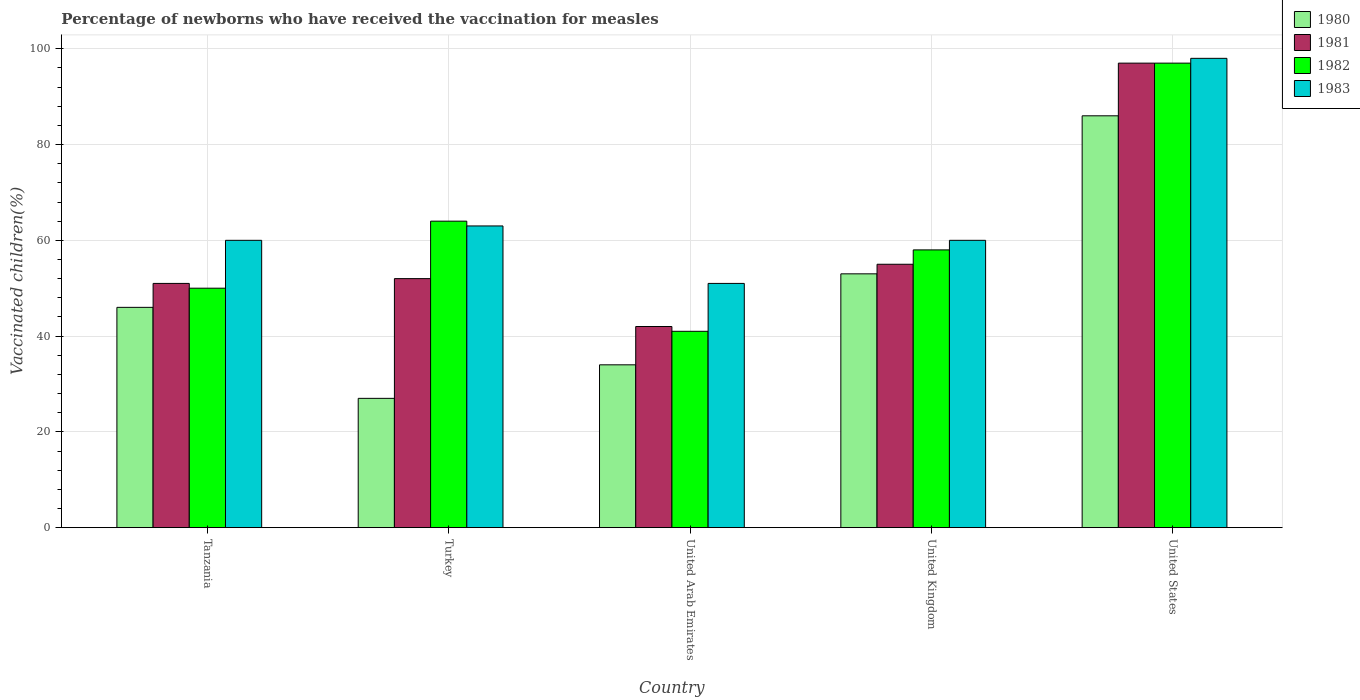How many different coloured bars are there?
Provide a short and direct response. 4. How many groups of bars are there?
Offer a very short reply. 5. How many bars are there on the 5th tick from the left?
Provide a succinct answer. 4. What is the label of the 3rd group of bars from the left?
Provide a short and direct response. United Arab Emirates. In how many cases, is the number of bars for a given country not equal to the number of legend labels?
Give a very brief answer. 0. What is the percentage of vaccinated children in 1980 in United Kingdom?
Make the answer very short. 53. Across all countries, what is the maximum percentage of vaccinated children in 1981?
Make the answer very short. 97. Across all countries, what is the minimum percentage of vaccinated children in 1983?
Provide a succinct answer. 51. In which country was the percentage of vaccinated children in 1983 maximum?
Give a very brief answer. United States. What is the total percentage of vaccinated children in 1982 in the graph?
Your response must be concise. 310. What is the difference between the percentage of vaccinated children in 1980 in Tanzania and that in Turkey?
Offer a terse response. 19. What is the difference between the percentage of vaccinated children of/in 1983 and percentage of vaccinated children of/in 1981 in Turkey?
Provide a short and direct response. 11. What is the ratio of the percentage of vaccinated children in 1982 in United Arab Emirates to that in United Kingdom?
Offer a terse response. 0.71. Is the percentage of vaccinated children in 1983 in Turkey less than that in United Arab Emirates?
Keep it short and to the point. No. Is the difference between the percentage of vaccinated children in 1983 in Tanzania and Turkey greater than the difference between the percentage of vaccinated children in 1981 in Tanzania and Turkey?
Your answer should be very brief. No. What is the difference between the highest and the second highest percentage of vaccinated children in 1982?
Provide a succinct answer. -33. Is the sum of the percentage of vaccinated children in 1980 in Turkey and United States greater than the maximum percentage of vaccinated children in 1983 across all countries?
Your answer should be very brief. Yes. Is it the case that in every country, the sum of the percentage of vaccinated children in 1983 and percentage of vaccinated children in 1980 is greater than the sum of percentage of vaccinated children in 1982 and percentage of vaccinated children in 1981?
Keep it short and to the point. No. What does the 2nd bar from the right in Tanzania represents?
Provide a short and direct response. 1982. How many countries are there in the graph?
Give a very brief answer. 5. What is the difference between two consecutive major ticks on the Y-axis?
Offer a very short reply. 20. Does the graph contain any zero values?
Ensure brevity in your answer.  No. Does the graph contain grids?
Your response must be concise. Yes. Where does the legend appear in the graph?
Give a very brief answer. Top right. How are the legend labels stacked?
Make the answer very short. Vertical. What is the title of the graph?
Make the answer very short. Percentage of newborns who have received the vaccination for measles. Does "2003" appear as one of the legend labels in the graph?
Your response must be concise. No. What is the label or title of the Y-axis?
Give a very brief answer. Vaccinated children(%). What is the Vaccinated children(%) in 1983 in Tanzania?
Your response must be concise. 60. What is the Vaccinated children(%) of 1982 in Turkey?
Provide a short and direct response. 64. What is the Vaccinated children(%) of 1982 in United Arab Emirates?
Your answer should be compact. 41. What is the Vaccinated children(%) in 1983 in United Kingdom?
Provide a succinct answer. 60. What is the Vaccinated children(%) of 1981 in United States?
Offer a terse response. 97. What is the Vaccinated children(%) in 1982 in United States?
Make the answer very short. 97. What is the Vaccinated children(%) in 1983 in United States?
Your answer should be compact. 98. Across all countries, what is the maximum Vaccinated children(%) in 1981?
Provide a succinct answer. 97. Across all countries, what is the maximum Vaccinated children(%) in 1982?
Your answer should be very brief. 97. Across all countries, what is the maximum Vaccinated children(%) in 1983?
Provide a short and direct response. 98. Across all countries, what is the minimum Vaccinated children(%) in 1980?
Give a very brief answer. 27. What is the total Vaccinated children(%) of 1980 in the graph?
Your answer should be compact. 246. What is the total Vaccinated children(%) in 1981 in the graph?
Keep it short and to the point. 297. What is the total Vaccinated children(%) in 1982 in the graph?
Offer a very short reply. 310. What is the total Vaccinated children(%) of 1983 in the graph?
Your answer should be compact. 332. What is the difference between the Vaccinated children(%) in 1981 in Tanzania and that in Turkey?
Offer a terse response. -1. What is the difference between the Vaccinated children(%) of 1982 in Tanzania and that in Turkey?
Provide a succinct answer. -14. What is the difference between the Vaccinated children(%) in 1983 in Tanzania and that in Turkey?
Your answer should be very brief. -3. What is the difference between the Vaccinated children(%) in 1983 in Tanzania and that in United Arab Emirates?
Your answer should be compact. 9. What is the difference between the Vaccinated children(%) in 1981 in Tanzania and that in United Kingdom?
Your response must be concise. -4. What is the difference between the Vaccinated children(%) in 1983 in Tanzania and that in United Kingdom?
Keep it short and to the point. 0. What is the difference between the Vaccinated children(%) of 1981 in Tanzania and that in United States?
Provide a succinct answer. -46. What is the difference between the Vaccinated children(%) in 1982 in Tanzania and that in United States?
Your answer should be compact. -47. What is the difference between the Vaccinated children(%) in 1983 in Tanzania and that in United States?
Offer a very short reply. -38. What is the difference between the Vaccinated children(%) in 1981 in Turkey and that in United Arab Emirates?
Give a very brief answer. 10. What is the difference between the Vaccinated children(%) in 1982 in Turkey and that in United Arab Emirates?
Your response must be concise. 23. What is the difference between the Vaccinated children(%) of 1983 in Turkey and that in United Arab Emirates?
Your answer should be compact. 12. What is the difference between the Vaccinated children(%) of 1980 in Turkey and that in United Kingdom?
Offer a terse response. -26. What is the difference between the Vaccinated children(%) in 1982 in Turkey and that in United Kingdom?
Provide a succinct answer. 6. What is the difference between the Vaccinated children(%) of 1983 in Turkey and that in United Kingdom?
Your response must be concise. 3. What is the difference between the Vaccinated children(%) of 1980 in Turkey and that in United States?
Your response must be concise. -59. What is the difference between the Vaccinated children(%) of 1981 in Turkey and that in United States?
Provide a succinct answer. -45. What is the difference between the Vaccinated children(%) in 1982 in Turkey and that in United States?
Your answer should be very brief. -33. What is the difference between the Vaccinated children(%) of 1983 in Turkey and that in United States?
Your answer should be compact. -35. What is the difference between the Vaccinated children(%) in 1980 in United Arab Emirates and that in United Kingdom?
Your answer should be compact. -19. What is the difference between the Vaccinated children(%) in 1983 in United Arab Emirates and that in United Kingdom?
Your response must be concise. -9. What is the difference between the Vaccinated children(%) of 1980 in United Arab Emirates and that in United States?
Ensure brevity in your answer.  -52. What is the difference between the Vaccinated children(%) in 1981 in United Arab Emirates and that in United States?
Your response must be concise. -55. What is the difference between the Vaccinated children(%) in 1982 in United Arab Emirates and that in United States?
Provide a short and direct response. -56. What is the difference between the Vaccinated children(%) of 1983 in United Arab Emirates and that in United States?
Provide a short and direct response. -47. What is the difference between the Vaccinated children(%) of 1980 in United Kingdom and that in United States?
Make the answer very short. -33. What is the difference between the Vaccinated children(%) of 1981 in United Kingdom and that in United States?
Offer a terse response. -42. What is the difference between the Vaccinated children(%) in 1982 in United Kingdom and that in United States?
Your answer should be very brief. -39. What is the difference between the Vaccinated children(%) in 1983 in United Kingdom and that in United States?
Give a very brief answer. -38. What is the difference between the Vaccinated children(%) of 1981 in Tanzania and the Vaccinated children(%) of 1982 in Turkey?
Give a very brief answer. -13. What is the difference between the Vaccinated children(%) of 1980 in Tanzania and the Vaccinated children(%) of 1982 in United Arab Emirates?
Give a very brief answer. 5. What is the difference between the Vaccinated children(%) in 1980 in Tanzania and the Vaccinated children(%) in 1983 in United Arab Emirates?
Offer a very short reply. -5. What is the difference between the Vaccinated children(%) of 1981 in Tanzania and the Vaccinated children(%) of 1983 in United Arab Emirates?
Your response must be concise. 0. What is the difference between the Vaccinated children(%) of 1981 in Tanzania and the Vaccinated children(%) of 1982 in United Kingdom?
Your answer should be very brief. -7. What is the difference between the Vaccinated children(%) in 1981 in Tanzania and the Vaccinated children(%) in 1983 in United Kingdom?
Your response must be concise. -9. What is the difference between the Vaccinated children(%) of 1982 in Tanzania and the Vaccinated children(%) of 1983 in United Kingdom?
Your answer should be very brief. -10. What is the difference between the Vaccinated children(%) in 1980 in Tanzania and the Vaccinated children(%) in 1981 in United States?
Provide a succinct answer. -51. What is the difference between the Vaccinated children(%) of 1980 in Tanzania and the Vaccinated children(%) of 1982 in United States?
Keep it short and to the point. -51. What is the difference between the Vaccinated children(%) in 1980 in Tanzania and the Vaccinated children(%) in 1983 in United States?
Offer a very short reply. -52. What is the difference between the Vaccinated children(%) of 1981 in Tanzania and the Vaccinated children(%) of 1982 in United States?
Offer a very short reply. -46. What is the difference between the Vaccinated children(%) in 1981 in Tanzania and the Vaccinated children(%) in 1983 in United States?
Your answer should be compact. -47. What is the difference between the Vaccinated children(%) of 1982 in Tanzania and the Vaccinated children(%) of 1983 in United States?
Give a very brief answer. -48. What is the difference between the Vaccinated children(%) of 1980 in Turkey and the Vaccinated children(%) of 1983 in United Arab Emirates?
Keep it short and to the point. -24. What is the difference between the Vaccinated children(%) in 1981 in Turkey and the Vaccinated children(%) in 1982 in United Arab Emirates?
Provide a short and direct response. 11. What is the difference between the Vaccinated children(%) of 1980 in Turkey and the Vaccinated children(%) of 1981 in United Kingdom?
Keep it short and to the point. -28. What is the difference between the Vaccinated children(%) of 1980 in Turkey and the Vaccinated children(%) of 1982 in United Kingdom?
Your answer should be very brief. -31. What is the difference between the Vaccinated children(%) of 1980 in Turkey and the Vaccinated children(%) of 1983 in United Kingdom?
Your answer should be compact. -33. What is the difference between the Vaccinated children(%) of 1982 in Turkey and the Vaccinated children(%) of 1983 in United Kingdom?
Offer a very short reply. 4. What is the difference between the Vaccinated children(%) in 1980 in Turkey and the Vaccinated children(%) in 1981 in United States?
Provide a succinct answer. -70. What is the difference between the Vaccinated children(%) of 1980 in Turkey and the Vaccinated children(%) of 1982 in United States?
Ensure brevity in your answer.  -70. What is the difference between the Vaccinated children(%) of 1980 in Turkey and the Vaccinated children(%) of 1983 in United States?
Your response must be concise. -71. What is the difference between the Vaccinated children(%) in 1981 in Turkey and the Vaccinated children(%) in 1982 in United States?
Keep it short and to the point. -45. What is the difference between the Vaccinated children(%) of 1981 in Turkey and the Vaccinated children(%) of 1983 in United States?
Ensure brevity in your answer.  -46. What is the difference between the Vaccinated children(%) of 1982 in Turkey and the Vaccinated children(%) of 1983 in United States?
Give a very brief answer. -34. What is the difference between the Vaccinated children(%) of 1980 in United Arab Emirates and the Vaccinated children(%) of 1982 in United Kingdom?
Provide a succinct answer. -24. What is the difference between the Vaccinated children(%) of 1980 in United Arab Emirates and the Vaccinated children(%) of 1983 in United Kingdom?
Your answer should be compact. -26. What is the difference between the Vaccinated children(%) of 1981 in United Arab Emirates and the Vaccinated children(%) of 1982 in United Kingdom?
Your response must be concise. -16. What is the difference between the Vaccinated children(%) of 1982 in United Arab Emirates and the Vaccinated children(%) of 1983 in United Kingdom?
Your response must be concise. -19. What is the difference between the Vaccinated children(%) in 1980 in United Arab Emirates and the Vaccinated children(%) in 1981 in United States?
Ensure brevity in your answer.  -63. What is the difference between the Vaccinated children(%) of 1980 in United Arab Emirates and the Vaccinated children(%) of 1982 in United States?
Your answer should be very brief. -63. What is the difference between the Vaccinated children(%) in 1980 in United Arab Emirates and the Vaccinated children(%) in 1983 in United States?
Ensure brevity in your answer.  -64. What is the difference between the Vaccinated children(%) of 1981 in United Arab Emirates and the Vaccinated children(%) of 1982 in United States?
Your answer should be very brief. -55. What is the difference between the Vaccinated children(%) in 1981 in United Arab Emirates and the Vaccinated children(%) in 1983 in United States?
Your answer should be very brief. -56. What is the difference between the Vaccinated children(%) of 1982 in United Arab Emirates and the Vaccinated children(%) of 1983 in United States?
Make the answer very short. -57. What is the difference between the Vaccinated children(%) of 1980 in United Kingdom and the Vaccinated children(%) of 1981 in United States?
Give a very brief answer. -44. What is the difference between the Vaccinated children(%) in 1980 in United Kingdom and the Vaccinated children(%) in 1982 in United States?
Your answer should be very brief. -44. What is the difference between the Vaccinated children(%) in 1980 in United Kingdom and the Vaccinated children(%) in 1983 in United States?
Provide a succinct answer. -45. What is the difference between the Vaccinated children(%) of 1981 in United Kingdom and the Vaccinated children(%) of 1982 in United States?
Ensure brevity in your answer.  -42. What is the difference between the Vaccinated children(%) in 1981 in United Kingdom and the Vaccinated children(%) in 1983 in United States?
Keep it short and to the point. -43. What is the difference between the Vaccinated children(%) in 1982 in United Kingdom and the Vaccinated children(%) in 1983 in United States?
Make the answer very short. -40. What is the average Vaccinated children(%) of 1980 per country?
Your answer should be compact. 49.2. What is the average Vaccinated children(%) in 1981 per country?
Offer a very short reply. 59.4. What is the average Vaccinated children(%) in 1983 per country?
Give a very brief answer. 66.4. What is the difference between the Vaccinated children(%) of 1980 and Vaccinated children(%) of 1981 in Tanzania?
Give a very brief answer. -5. What is the difference between the Vaccinated children(%) of 1981 and Vaccinated children(%) of 1982 in Tanzania?
Your answer should be very brief. 1. What is the difference between the Vaccinated children(%) in 1982 and Vaccinated children(%) in 1983 in Tanzania?
Keep it short and to the point. -10. What is the difference between the Vaccinated children(%) of 1980 and Vaccinated children(%) of 1982 in Turkey?
Provide a short and direct response. -37. What is the difference between the Vaccinated children(%) in 1980 and Vaccinated children(%) in 1983 in Turkey?
Your answer should be very brief. -36. What is the difference between the Vaccinated children(%) of 1981 and Vaccinated children(%) of 1982 in Turkey?
Keep it short and to the point. -12. What is the difference between the Vaccinated children(%) of 1981 and Vaccinated children(%) of 1983 in Turkey?
Ensure brevity in your answer.  -11. What is the difference between the Vaccinated children(%) in 1982 and Vaccinated children(%) in 1983 in Turkey?
Keep it short and to the point. 1. What is the difference between the Vaccinated children(%) of 1980 and Vaccinated children(%) of 1981 in United Arab Emirates?
Offer a very short reply. -8. What is the difference between the Vaccinated children(%) in 1980 and Vaccinated children(%) in 1982 in United Arab Emirates?
Provide a succinct answer. -7. What is the difference between the Vaccinated children(%) of 1980 and Vaccinated children(%) of 1983 in United Arab Emirates?
Your answer should be compact. -17. What is the difference between the Vaccinated children(%) in 1981 and Vaccinated children(%) in 1983 in United Arab Emirates?
Give a very brief answer. -9. What is the difference between the Vaccinated children(%) of 1980 and Vaccinated children(%) of 1981 in United Kingdom?
Give a very brief answer. -2. What is the difference between the Vaccinated children(%) of 1980 and Vaccinated children(%) of 1982 in United Kingdom?
Make the answer very short. -5. What is the difference between the Vaccinated children(%) in 1981 and Vaccinated children(%) in 1982 in United Kingdom?
Your answer should be compact. -3. What is the difference between the Vaccinated children(%) in 1981 and Vaccinated children(%) in 1983 in United Kingdom?
Provide a short and direct response. -5. What is the difference between the Vaccinated children(%) in 1982 and Vaccinated children(%) in 1983 in United Kingdom?
Your response must be concise. -2. What is the difference between the Vaccinated children(%) in 1980 and Vaccinated children(%) in 1981 in United States?
Ensure brevity in your answer.  -11. What is the difference between the Vaccinated children(%) of 1980 and Vaccinated children(%) of 1983 in United States?
Ensure brevity in your answer.  -12. What is the difference between the Vaccinated children(%) of 1981 and Vaccinated children(%) of 1982 in United States?
Provide a short and direct response. 0. What is the difference between the Vaccinated children(%) of 1981 and Vaccinated children(%) of 1983 in United States?
Your response must be concise. -1. What is the difference between the Vaccinated children(%) of 1982 and Vaccinated children(%) of 1983 in United States?
Provide a succinct answer. -1. What is the ratio of the Vaccinated children(%) in 1980 in Tanzania to that in Turkey?
Offer a very short reply. 1.7. What is the ratio of the Vaccinated children(%) of 1981 in Tanzania to that in Turkey?
Provide a succinct answer. 0.98. What is the ratio of the Vaccinated children(%) of 1982 in Tanzania to that in Turkey?
Make the answer very short. 0.78. What is the ratio of the Vaccinated children(%) of 1983 in Tanzania to that in Turkey?
Provide a short and direct response. 0.95. What is the ratio of the Vaccinated children(%) in 1980 in Tanzania to that in United Arab Emirates?
Provide a short and direct response. 1.35. What is the ratio of the Vaccinated children(%) of 1981 in Tanzania to that in United Arab Emirates?
Your answer should be very brief. 1.21. What is the ratio of the Vaccinated children(%) of 1982 in Tanzania to that in United Arab Emirates?
Give a very brief answer. 1.22. What is the ratio of the Vaccinated children(%) in 1983 in Tanzania to that in United Arab Emirates?
Offer a very short reply. 1.18. What is the ratio of the Vaccinated children(%) in 1980 in Tanzania to that in United Kingdom?
Ensure brevity in your answer.  0.87. What is the ratio of the Vaccinated children(%) in 1981 in Tanzania to that in United Kingdom?
Make the answer very short. 0.93. What is the ratio of the Vaccinated children(%) in 1982 in Tanzania to that in United Kingdom?
Your answer should be very brief. 0.86. What is the ratio of the Vaccinated children(%) of 1980 in Tanzania to that in United States?
Keep it short and to the point. 0.53. What is the ratio of the Vaccinated children(%) in 1981 in Tanzania to that in United States?
Offer a terse response. 0.53. What is the ratio of the Vaccinated children(%) in 1982 in Tanzania to that in United States?
Offer a very short reply. 0.52. What is the ratio of the Vaccinated children(%) of 1983 in Tanzania to that in United States?
Keep it short and to the point. 0.61. What is the ratio of the Vaccinated children(%) in 1980 in Turkey to that in United Arab Emirates?
Give a very brief answer. 0.79. What is the ratio of the Vaccinated children(%) in 1981 in Turkey to that in United Arab Emirates?
Offer a very short reply. 1.24. What is the ratio of the Vaccinated children(%) in 1982 in Turkey to that in United Arab Emirates?
Provide a succinct answer. 1.56. What is the ratio of the Vaccinated children(%) of 1983 in Turkey to that in United Arab Emirates?
Your response must be concise. 1.24. What is the ratio of the Vaccinated children(%) of 1980 in Turkey to that in United Kingdom?
Keep it short and to the point. 0.51. What is the ratio of the Vaccinated children(%) in 1981 in Turkey to that in United Kingdom?
Keep it short and to the point. 0.95. What is the ratio of the Vaccinated children(%) of 1982 in Turkey to that in United Kingdom?
Provide a short and direct response. 1.1. What is the ratio of the Vaccinated children(%) in 1983 in Turkey to that in United Kingdom?
Your answer should be very brief. 1.05. What is the ratio of the Vaccinated children(%) in 1980 in Turkey to that in United States?
Give a very brief answer. 0.31. What is the ratio of the Vaccinated children(%) in 1981 in Turkey to that in United States?
Offer a terse response. 0.54. What is the ratio of the Vaccinated children(%) of 1982 in Turkey to that in United States?
Your response must be concise. 0.66. What is the ratio of the Vaccinated children(%) of 1983 in Turkey to that in United States?
Provide a succinct answer. 0.64. What is the ratio of the Vaccinated children(%) of 1980 in United Arab Emirates to that in United Kingdom?
Offer a terse response. 0.64. What is the ratio of the Vaccinated children(%) in 1981 in United Arab Emirates to that in United Kingdom?
Keep it short and to the point. 0.76. What is the ratio of the Vaccinated children(%) in 1982 in United Arab Emirates to that in United Kingdom?
Make the answer very short. 0.71. What is the ratio of the Vaccinated children(%) of 1980 in United Arab Emirates to that in United States?
Your answer should be compact. 0.4. What is the ratio of the Vaccinated children(%) of 1981 in United Arab Emirates to that in United States?
Your answer should be very brief. 0.43. What is the ratio of the Vaccinated children(%) of 1982 in United Arab Emirates to that in United States?
Offer a very short reply. 0.42. What is the ratio of the Vaccinated children(%) in 1983 in United Arab Emirates to that in United States?
Offer a terse response. 0.52. What is the ratio of the Vaccinated children(%) of 1980 in United Kingdom to that in United States?
Your response must be concise. 0.62. What is the ratio of the Vaccinated children(%) in 1981 in United Kingdom to that in United States?
Your answer should be very brief. 0.57. What is the ratio of the Vaccinated children(%) of 1982 in United Kingdom to that in United States?
Provide a short and direct response. 0.6. What is the ratio of the Vaccinated children(%) in 1983 in United Kingdom to that in United States?
Provide a short and direct response. 0.61. What is the difference between the highest and the second highest Vaccinated children(%) in 1983?
Offer a very short reply. 35. What is the difference between the highest and the lowest Vaccinated children(%) of 1980?
Your answer should be compact. 59. What is the difference between the highest and the lowest Vaccinated children(%) of 1981?
Offer a terse response. 55. What is the difference between the highest and the lowest Vaccinated children(%) of 1982?
Ensure brevity in your answer.  56. 